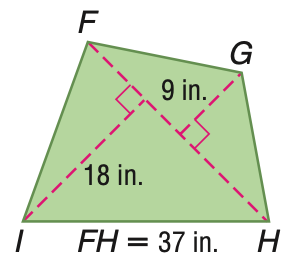Answer the mathemtical geometry problem and directly provide the correct option letter.
Question: Find the area of the quadrilateral.
Choices: A: 405 B: 499.5 C: 684.5 D: 999 B 